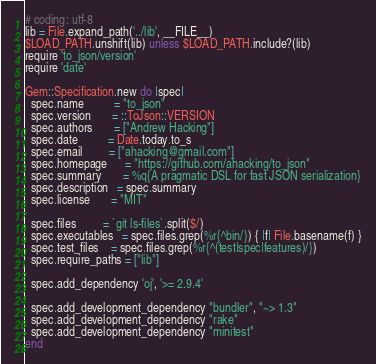<code> <loc_0><loc_0><loc_500><loc_500><_Ruby_># coding: utf-8
lib = File.expand_path('../lib', __FILE__)
$LOAD_PATH.unshift(lib) unless $LOAD_PATH.include?(lib)
require 'to_json/version'
require 'date'

Gem::Specification.new do |spec|
  spec.name          = "to_json"
  spec.version       = ::ToJson::VERSION
  spec.authors       = ["Andrew Hacking"]
  spec.date          = Date.today.to_s
  spec.email         = ["ahacking@gmail.com"]
  spec.homepage      = "https://github.com/ahacking/to_json"
  spec.summary       = %q{A pragmatic DSL for fast JSON serialization}
  spec.description   = spec.summary
  spec.license       = "MIT"

  spec.files         = `git ls-files`.split($/)
  spec.executables   = spec.files.grep(%r{^bin/}) { |f| File.basename(f) }
  spec.test_files    = spec.files.grep(%r{^(test|spec|features)/})
  spec.require_paths = ["lib"]

  spec.add_dependency 'oj', '>= 2.9.4'

  spec.add_development_dependency "bundler", "~> 1.3"
  spec.add_development_dependency "rake"
  spec.add_development_dependency "minitest"
end
</code> 